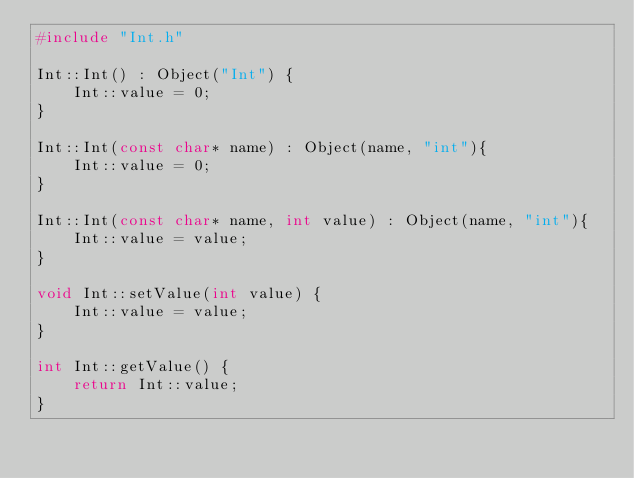Convert code to text. <code><loc_0><loc_0><loc_500><loc_500><_C++_>#include "Int.h"

Int::Int() : Object("Int") {
	Int::value = 0;
}

Int::Int(const char* name) : Object(name, "int"){
	Int::value = 0;
}

Int::Int(const char* name, int value) : Object(name, "int"){
	Int::value = value;
}

void Int::setValue(int value) {
	Int::value = value;
}

int Int::getValue() {
	return Int::value;
}</code> 